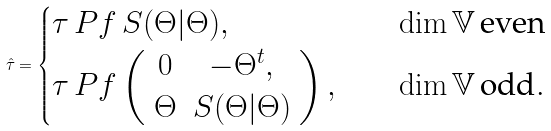Convert formula to latex. <formula><loc_0><loc_0><loc_500><loc_500>\hat { \tau } = \begin{cases} \tau \, P f \, S ( \Theta | \Theta ) , & \dim \mathbb { V } \, \text {even} \\ \tau \, P f \left ( \begin{array} { c c } 0 & - \Theta ^ { t } , \\ \Theta & S ( \Theta | \Theta ) \end{array} \right ) , \quad & \dim \mathbb { V } \, \text {odd} . \end{cases}</formula> 